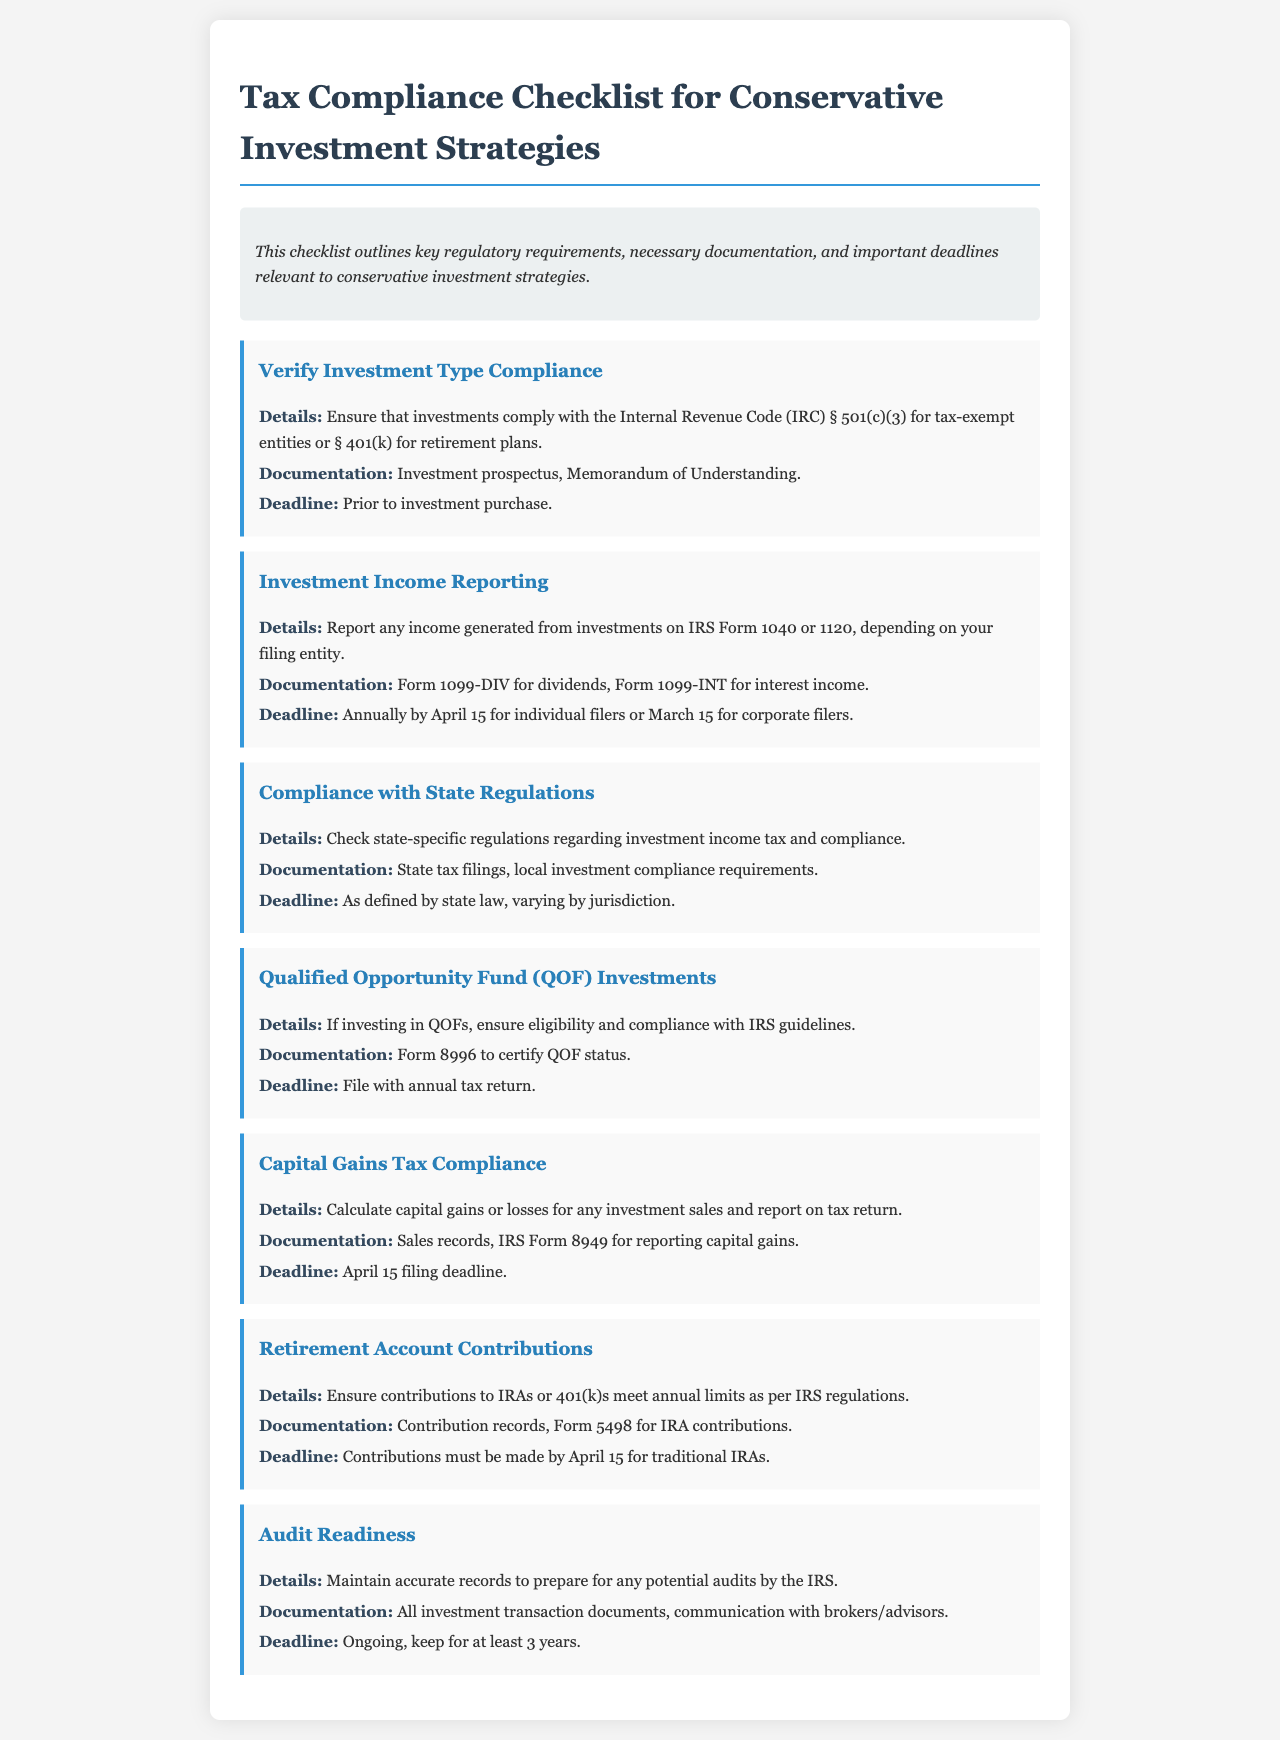what is the first item on the checklist? The first item listed in the checklist is related to verifying investment type compliance.
Answer: Verify Investment Type Compliance what form is used for reporting investment income? The document specifies using IRS Form 1040 or 1120 for reporting investment income.
Answer: IRS Form 1040 or 1120 what is the deadline for individual filers to report investment income? The deadline for individual filers to report investment income is annually by April 15.
Answer: April 15 which form is needed to certify QOF status? To certify QOF status, Form 8996 is required according to the checklist.
Answer: Form 8996 how long should records be kept for audit readiness? The document indicates that records should be kept for at least 3 years for audit readiness.
Answer: 3 years what is the documentation needed for IRA contributions? For IRA contributions, the required documentation is Form 5498.
Answer: Form 5498 which regulation section must be checked for investment type compliance? The relevant regulation section to check is IRC § 501(c)(3) or § 401(k).
Answer: IRC § 501(c)(3) or § 401(k) what is the primary purpose of this document? The primary purpose of the document is to outline key regulatory requirements for investment strategies.
Answer: Outline key regulatory requirements 